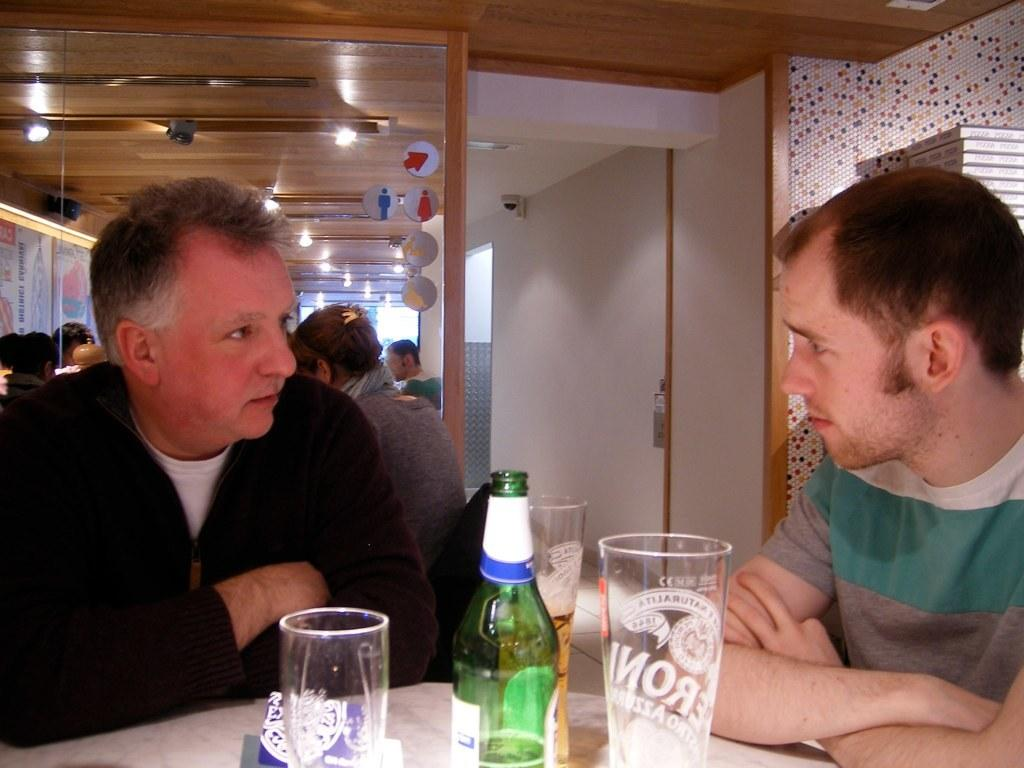What are the two people in the image doing? The two people in the image are having a conversation. Where are the two people positioned in relation to each other? One person is on the left side, and the other is on the right side. Can you describe the background of the image? There are four people visible in the background of the image. What type of spark can be seen between the two people having a conversation in the image? A: There is no spark visible between the two people having a conversation in the image. Can you describe the goose that is present in the image? There is no goose present in the image. 